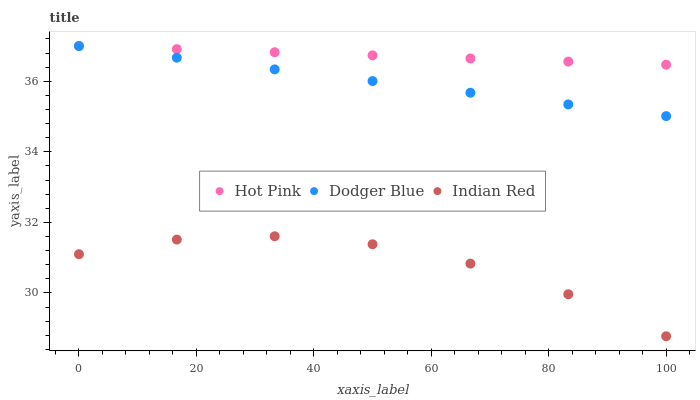Does Indian Red have the minimum area under the curve?
Answer yes or no. Yes. Does Hot Pink have the maximum area under the curve?
Answer yes or no. Yes. Does Dodger Blue have the minimum area under the curve?
Answer yes or no. No. Does Dodger Blue have the maximum area under the curve?
Answer yes or no. No. Is Dodger Blue the smoothest?
Answer yes or no. Yes. Is Indian Red the roughest?
Answer yes or no. Yes. Is Indian Red the smoothest?
Answer yes or no. No. Is Dodger Blue the roughest?
Answer yes or no. No. Does Indian Red have the lowest value?
Answer yes or no. Yes. Does Dodger Blue have the lowest value?
Answer yes or no. No. Does Dodger Blue have the highest value?
Answer yes or no. Yes. Does Indian Red have the highest value?
Answer yes or no. No. Is Indian Red less than Hot Pink?
Answer yes or no. Yes. Is Hot Pink greater than Indian Red?
Answer yes or no. Yes. Does Dodger Blue intersect Hot Pink?
Answer yes or no. Yes. Is Dodger Blue less than Hot Pink?
Answer yes or no. No. Is Dodger Blue greater than Hot Pink?
Answer yes or no. No. Does Indian Red intersect Hot Pink?
Answer yes or no. No. 